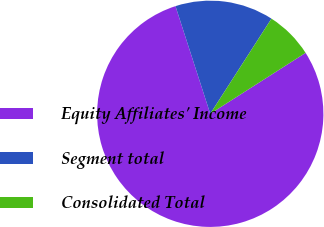Convert chart. <chart><loc_0><loc_0><loc_500><loc_500><pie_chart><fcel>Equity Affiliates' Income<fcel>Segment total<fcel>Consolidated Total<nl><fcel>79.08%<fcel>14.07%<fcel>6.85%<nl></chart> 